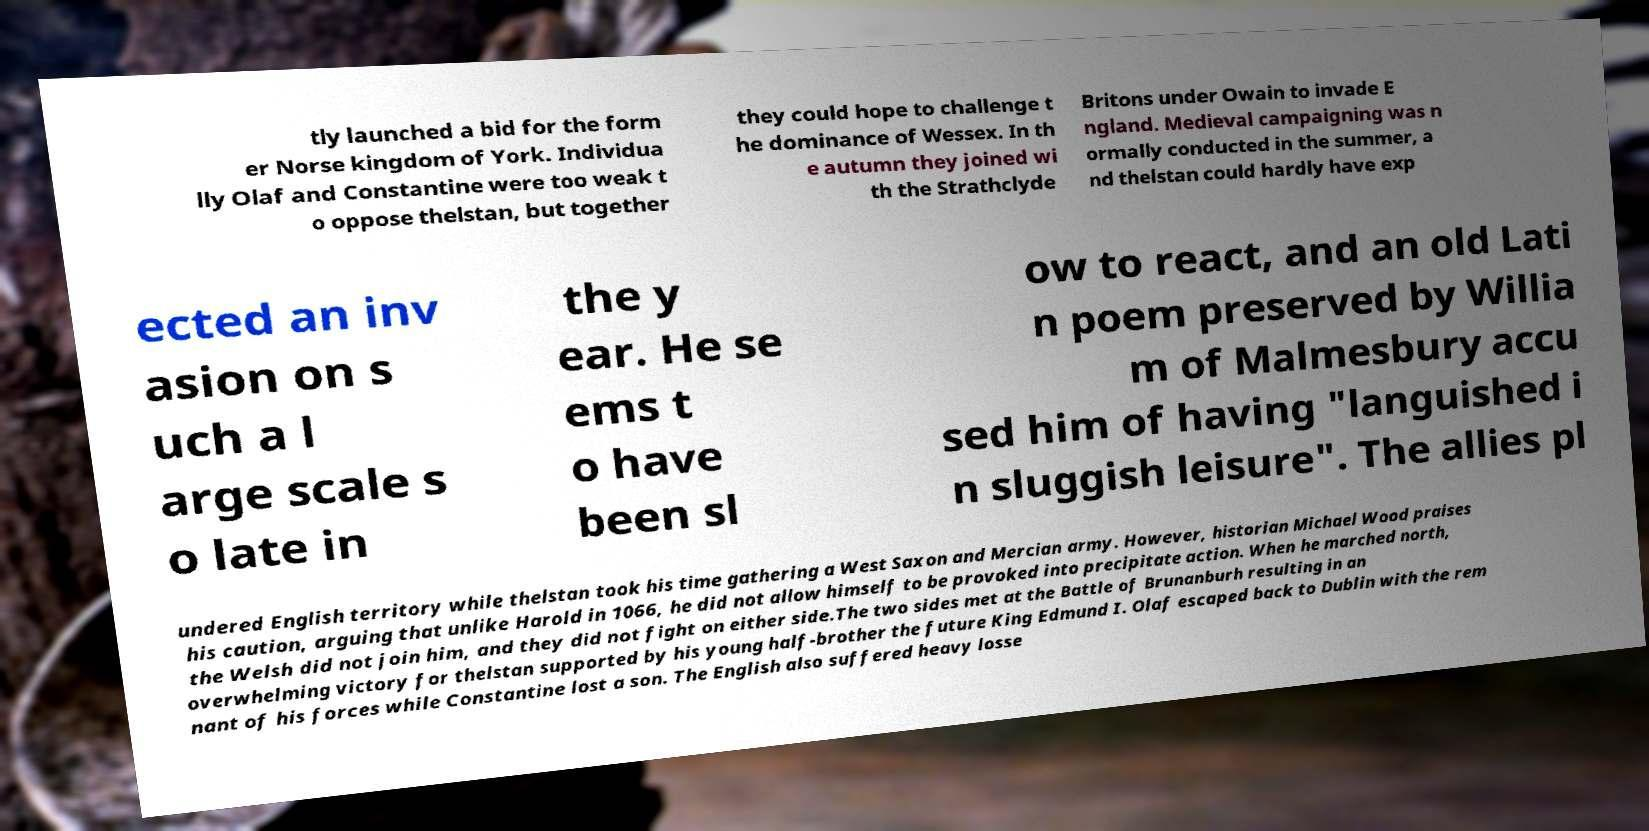Could you assist in decoding the text presented in this image and type it out clearly? tly launched a bid for the form er Norse kingdom of York. Individua lly Olaf and Constantine were too weak t o oppose thelstan, but together they could hope to challenge t he dominance of Wessex. In th e autumn they joined wi th the Strathclyde Britons under Owain to invade E ngland. Medieval campaigning was n ormally conducted in the summer, a nd thelstan could hardly have exp ected an inv asion on s uch a l arge scale s o late in the y ear. He se ems t o have been sl ow to react, and an old Lati n poem preserved by Willia m of Malmesbury accu sed him of having "languished i n sluggish leisure". The allies pl undered English territory while thelstan took his time gathering a West Saxon and Mercian army. However, historian Michael Wood praises his caution, arguing that unlike Harold in 1066, he did not allow himself to be provoked into precipitate action. When he marched north, the Welsh did not join him, and they did not fight on either side.The two sides met at the Battle of Brunanburh resulting in an overwhelming victory for thelstan supported by his young half-brother the future King Edmund I. Olaf escaped back to Dublin with the rem nant of his forces while Constantine lost a son. The English also suffered heavy losse 